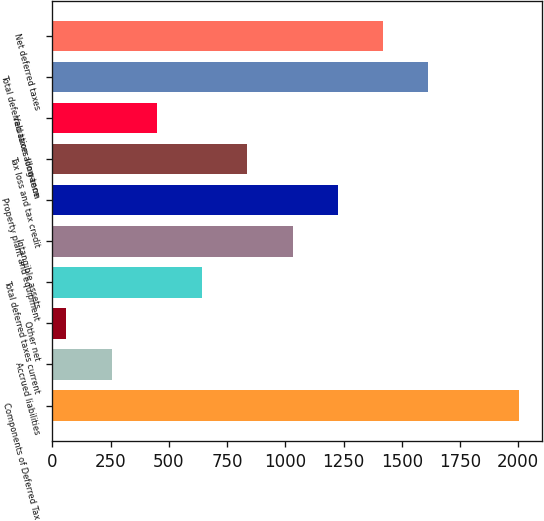Convert chart. <chart><loc_0><loc_0><loc_500><loc_500><bar_chart><fcel>Components of Deferred Tax<fcel>Accrued liabilities<fcel>Other net<fcel>Total deferred taxes current<fcel>Intangible assets<fcel>Property plant and equipment<fcel>Tax loss and tax credit<fcel>Valuation allowance<fcel>Total deferred taxes long-term<fcel>Net deferred taxes<nl><fcel>2003<fcel>254.03<fcel>59.7<fcel>642.69<fcel>1031.35<fcel>1225.68<fcel>837.02<fcel>448.36<fcel>1614.34<fcel>1420.01<nl></chart> 